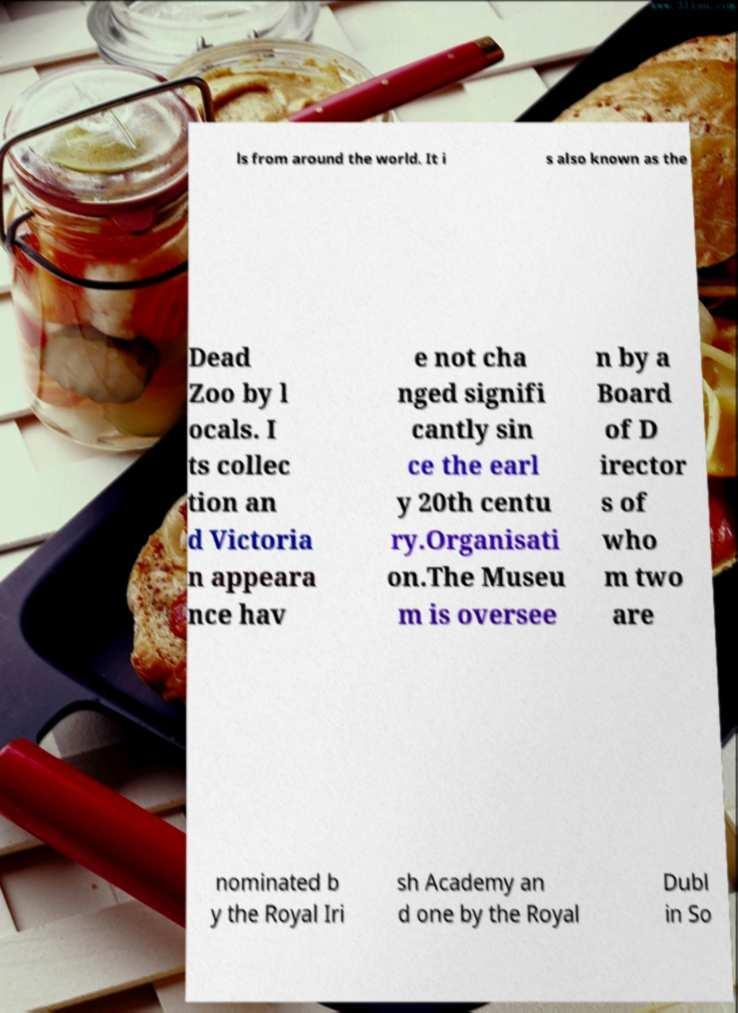For documentation purposes, I need the text within this image transcribed. Could you provide that? ls from around the world. It i s also known as the Dead Zoo by l ocals. I ts collec tion an d Victoria n appeara nce hav e not cha nged signifi cantly sin ce the earl y 20th centu ry.Organisati on.The Museu m is oversee n by a Board of D irector s of who m two are nominated b y the Royal Iri sh Academy an d one by the Royal Dubl in So 